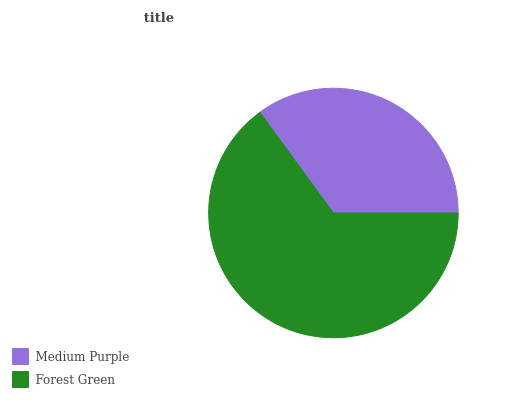Is Medium Purple the minimum?
Answer yes or no. Yes. Is Forest Green the maximum?
Answer yes or no. Yes. Is Forest Green the minimum?
Answer yes or no. No. Is Forest Green greater than Medium Purple?
Answer yes or no. Yes. Is Medium Purple less than Forest Green?
Answer yes or no. Yes. Is Medium Purple greater than Forest Green?
Answer yes or no. No. Is Forest Green less than Medium Purple?
Answer yes or no. No. Is Forest Green the high median?
Answer yes or no. Yes. Is Medium Purple the low median?
Answer yes or no. Yes. Is Medium Purple the high median?
Answer yes or no. No. Is Forest Green the low median?
Answer yes or no. No. 